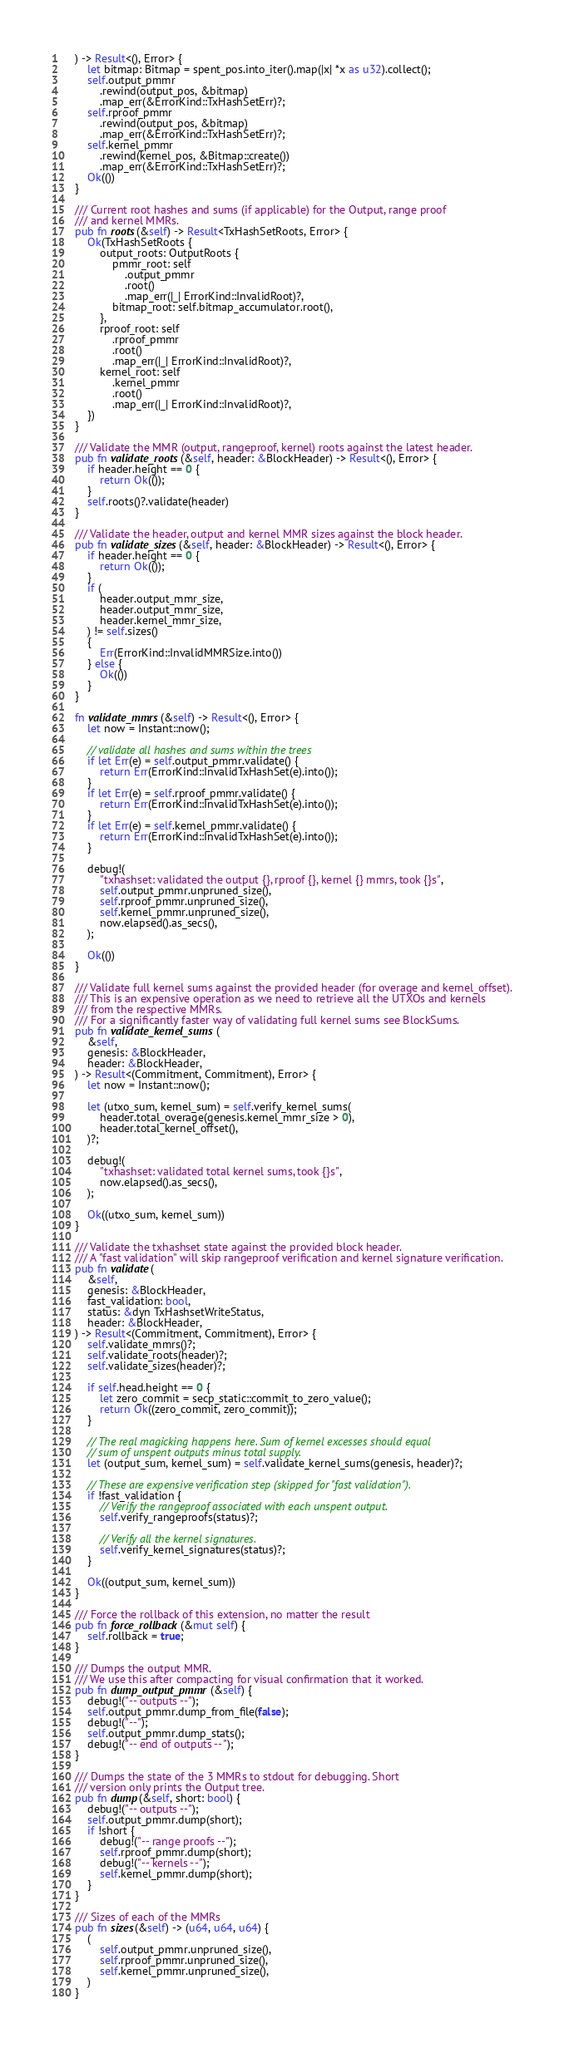<code> <loc_0><loc_0><loc_500><loc_500><_Rust_>	) -> Result<(), Error> {
		let bitmap: Bitmap = spent_pos.into_iter().map(|x| *x as u32).collect();
		self.output_pmmr
			.rewind(output_pos, &bitmap)
			.map_err(&ErrorKind::TxHashSetErr)?;
		self.rproof_pmmr
			.rewind(output_pos, &bitmap)
			.map_err(&ErrorKind::TxHashSetErr)?;
		self.kernel_pmmr
			.rewind(kernel_pos, &Bitmap::create())
			.map_err(&ErrorKind::TxHashSetErr)?;
		Ok(())
	}

	/// Current root hashes and sums (if applicable) for the Output, range proof
	/// and kernel MMRs.
	pub fn roots(&self) -> Result<TxHashSetRoots, Error> {
		Ok(TxHashSetRoots {
			output_roots: OutputRoots {
				pmmr_root: self
					.output_pmmr
					.root()
					.map_err(|_| ErrorKind::InvalidRoot)?,
				bitmap_root: self.bitmap_accumulator.root(),
			},
			rproof_root: self
				.rproof_pmmr
				.root()
				.map_err(|_| ErrorKind::InvalidRoot)?,
			kernel_root: self
				.kernel_pmmr
				.root()
				.map_err(|_| ErrorKind::InvalidRoot)?,
		})
	}

	/// Validate the MMR (output, rangeproof, kernel) roots against the latest header.
	pub fn validate_roots(&self, header: &BlockHeader) -> Result<(), Error> {
		if header.height == 0 {
			return Ok(());
		}
		self.roots()?.validate(header)
	}

	/// Validate the header, output and kernel MMR sizes against the block header.
	pub fn validate_sizes(&self, header: &BlockHeader) -> Result<(), Error> {
		if header.height == 0 {
			return Ok(());
		}
		if (
			header.output_mmr_size,
			header.output_mmr_size,
			header.kernel_mmr_size,
		) != self.sizes()
		{
			Err(ErrorKind::InvalidMMRSize.into())
		} else {
			Ok(())
		}
	}

	fn validate_mmrs(&self) -> Result<(), Error> {
		let now = Instant::now();

		// validate all hashes and sums within the trees
		if let Err(e) = self.output_pmmr.validate() {
			return Err(ErrorKind::InvalidTxHashSet(e).into());
		}
		if let Err(e) = self.rproof_pmmr.validate() {
			return Err(ErrorKind::InvalidTxHashSet(e).into());
		}
		if let Err(e) = self.kernel_pmmr.validate() {
			return Err(ErrorKind::InvalidTxHashSet(e).into());
		}

		debug!(
			"txhashset: validated the output {}, rproof {}, kernel {} mmrs, took {}s",
			self.output_pmmr.unpruned_size(),
			self.rproof_pmmr.unpruned_size(),
			self.kernel_pmmr.unpruned_size(),
			now.elapsed().as_secs(),
		);

		Ok(())
	}

	/// Validate full kernel sums against the provided header (for overage and kernel_offset).
	/// This is an expensive operation as we need to retrieve all the UTXOs and kernels
	/// from the respective MMRs.
	/// For a significantly faster way of validating full kernel sums see BlockSums.
	pub fn validate_kernel_sums(
		&self,
		genesis: &BlockHeader,
		header: &BlockHeader,
	) -> Result<(Commitment, Commitment), Error> {
		let now = Instant::now();

		let (utxo_sum, kernel_sum) = self.verify_kernel_sums(
			header.total_overage(genesis.kernel_mmr_size > 0),
			header.total_kernel_offset(),
		)?;

		debug!(
			"txhashset: validated total kernel sums, took {}s",
			now.elapsed().as_secs(),
		);

		Ok((utxo_sum, kernel_sum))
	}

	/// Validate the txhashset state against the provided block header.
	/// A "fast validation" will skip rangeproof verification and kernel signature verification.
	pub fn validate(
		&self,
		genesis: &BlockHeader,
		fast_validation: bool,
		status: &dyn TxHashsetWriteStatus,
		header: &BlockHeader,
	) -> Result<(Commitment, Commitment), Error> {
		self.validate_mmrs()?;
		self.validate_roots(header)?;
		self.validate_sizes(header)?;

		if self.head.height == 0 {
			let zero_commit = secp_static::commit_to_zero_value();
			return Ok((zero_commit, zero_commit));
		}

		// The real magicking happens here. Sum of kernel excesses should equal
		// sum of unspent outputs minus total supply.
		let (output_sum, kernel_sum) = self.validate_kernel_sums(genesis, header)?;

		// These are expensive verification step (skipped for "fast validation").
		if !fast_validation {
			// Verify the rangeproof associated with each unspent output.
			self.verify_rangeproofs(status)?;

			// Verify all the kernel signatures.
			self.verify_kernel_signatures(status)?;
		}

		Ok((output_sum, kernel_sum))
	}

	/// Force the rollback of this extension, no matter the result
	pub fn force_rollback(&mut self) {
		self.rollback = true;
	}

	/// Dumps the output MMR.
	/// We use this after compacting for visual confirmation that it worked.
	pub fn dump_output_pmmr(&self) {
		debug!("-- outputs --");
		self.output_pmmr.dump_from_file(false);
		debug!("--");
		self.output_pmmr.dump_stats();
		debug!("-- end of outputs --");
	}

	/// Dumps the state of the 3 MMRs to stdout for debugging. Short
	/// version only prints the Output tree.
	pub fn dump(&self, short: bool) {
		debug!("-- outputs --");
		self.output_pmmr.dump(short);
		if !short {
			debug!("-- range proofs --");
			self.rproof_pmmr.dump(short);
			debug!("-- kernels --");
			self.kernel_pmmr.dump(short);
		}
	}

	/// Sizes of each of the MMRs
	pub fn sizes(&self) -> (u64, u64, u64) {
		(
			self.output_pmmr.unpruned_size(),
			self.rproof_pmmr.unpruned_size(),
			self.kernel_pmmr.unpruned_size(),
		)
	}
</code> 